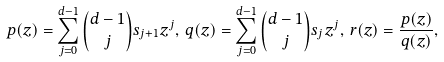<formula> <loc_0><loc_0><loc_500><loc_500>p ( z ) = \sum _ { j = 0 } ^ { d - 1 } { d - 1 \choose j } s _ { j + 1 } z ^ { j } , \, q ( z ) = \sum _ { j = 0 } ^ { d - 1 } { d - 1 \choose j } s _ { j } z ^ { j } , \, r ( z ) = \frac { p ( z ) } { q ( z ) } , \,</formula> 